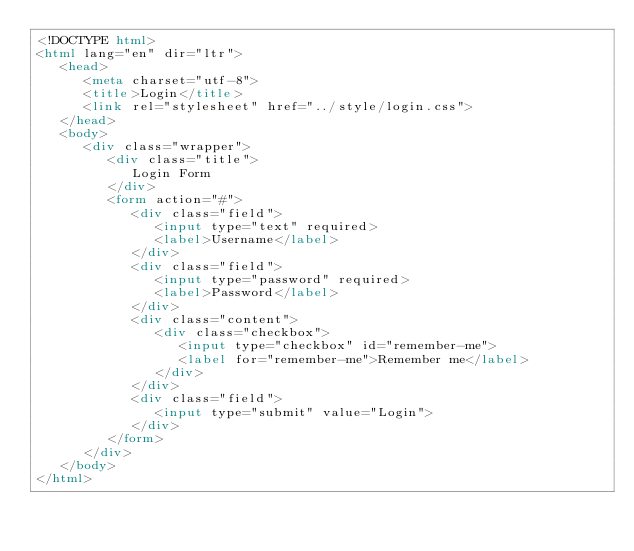Convert code to text. <code><loc_0><loc_0><loc_500><loc_500><_HTML_><!DOCTYPE html>
<html lang="en" dir="ltr">
   <head>
      <meta charset="utf-8">
      <title>Login</title>
      <link rel="stylesheet" href="../style/login.css">
   </head>
   <body>
      <div class="wrapper">
         <div class="title">
            Login Form
         </div>
         <form action="#">
            <div class="field">
               <input type="text" required>
               <label>Username</label>
            </div>
            <div class="field">
               <input type="password" required>
               <label>Password</label>
            </div>
            <div class="content">
               <div class="checkbox">
                  <input type="checkbox" id="remember-me">
                  <label for="remember-me">Remember me</label>
               </div>
            </div>
            <div class="field">
               <input type="submit" value="Login">
            </div>
         </form>
      </div>
   </body>
</html></code> 